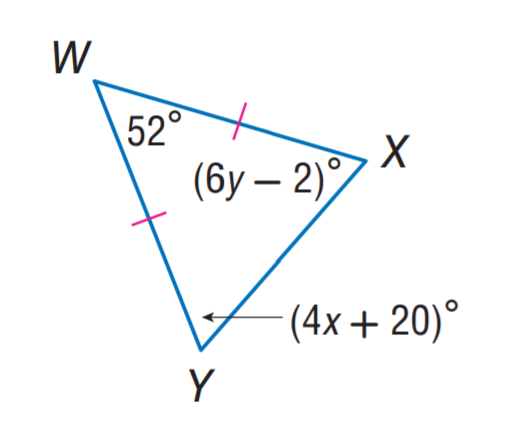Answer the mathemtical geometry problem and directly provide the correct option letter.
Question: Find x.
Choices: A: 6 B: 11 C: 12 D: 20 B 